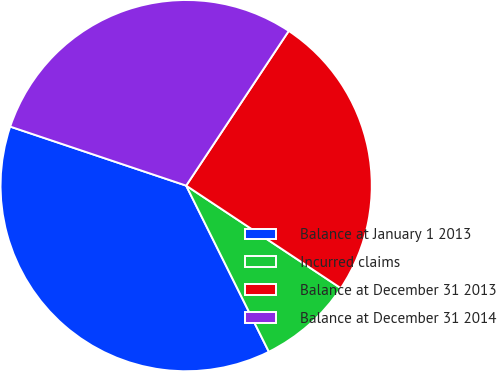Convert chart to OTSL. <chart><loc_0><loc_0><loc_500><loc_500><pie_chart><fcel>Balance at January 1 2013<fcel>Incurred claims<fcel>Balance at December 31 2013<fcel>Balance at December 31 2014<nl><fcel>37.5%<fcel>8.33%<fcel>25.0%<fcel>29.17%<nl></chart> 